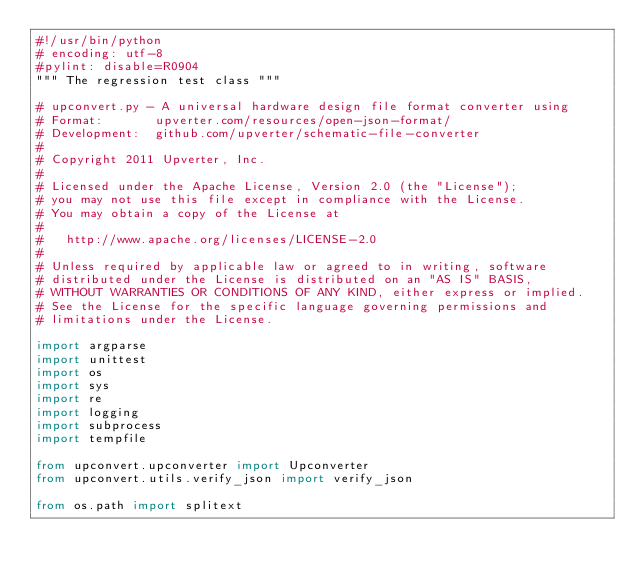Convert code to text. <code><loc_0><loc_0><loc_500><loc_500><_Python_>#!/usr/bin/python
# encoding: utf-8
#pylint: disable=R0904
""" The regression test class """

# upconvert.py - A universal hardware design file format converter using
# Format:       upverter.com/resources/open-json-format/
# Development:  github.com/upverter/schematic-file-converter
#
# Copyright 2011 Upverter, Inc.
#
# Licensed under the Apache License, Version 2.0 (the "License");
# you may not use this file except in compliance with the License.
# You may obtain a copy of the License at
#
#   http://www.apache.org/licenses/LICENSE-2.0
#
# Unless required by applicable law or agreed to in writing, software
# distributed under the License is distributed on an "AS IS" BASIS,
# WITHOUT WARRANTIES OR CONDITIONS OF ANY KIND, either express or implied.
# See the License for the specific language governing permissions and
# limitations under the License.

import argparse
import unittest
import os
import sys
import re
import logging
import subprocess
import tempfile

from upconvert.upconverter import Upconverter
from upconvert.utils.verify_json import verify_json

from os.path import splitext

</code> 